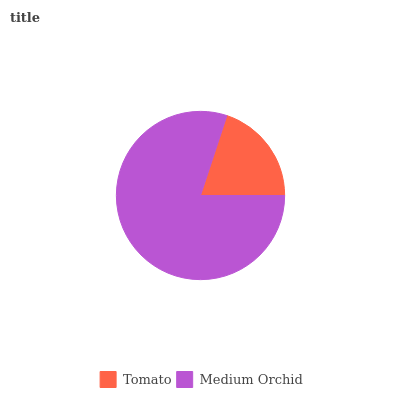Is Tomato the minimum?
Answer yes or no. Yes. Is Medium Orchid the maximum?
Answer yes or no. Yes. Is Medium Orchid the minimum?
Answer yes or no. No. Is Medium Orchid greater than Tomato?
Answer yes or no. Yes. Is Tomato less than Medium Orchid?
Answer yes or no. Yes. Is Tomato greater than Medium Orchid?
Answer yes or no. No. Is Medium Orchid less than Tomato?
Answer yes or no. No. Is Medium Orchid the high median?
Answer yes or no. Yes. Is Tomato the low median?
Answer yes or no. Yes. Is Tomato the high median?
Answer yes or no. No. Is Medium Orchid the low median?
Answer yes or no. No. 